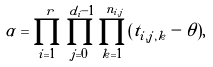Convert formula to latex. <formula><loc_0><loc_0><loc_500><loc_500>\alpha = \prod _ { i = 1 } ^ { r } \prod _ { j = 0 } ^ { d _ { i } - 1 } \prod _ { k = 1 } ^ { n _ { i , j } } ( t _ { i , j , k } - \theta ) ,</formula> 